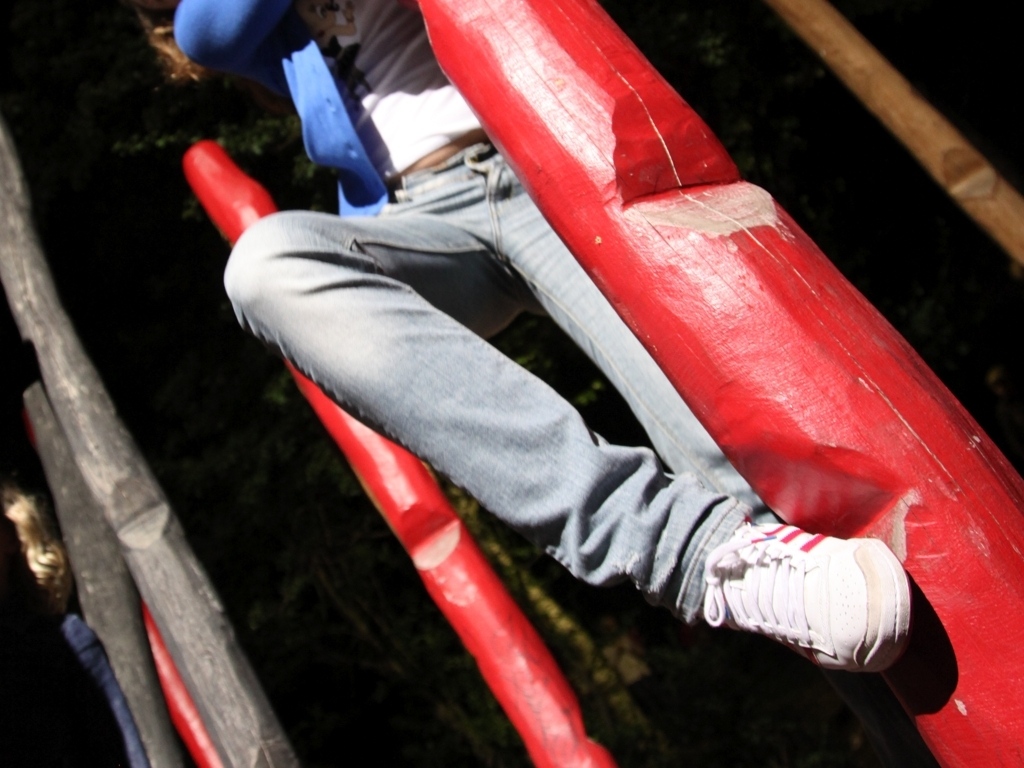Is there any visible noise or graininess in the image? Upon close inspection, the image maintains a good level of clarity with no significant noise or graininess affecting the visual quality. 